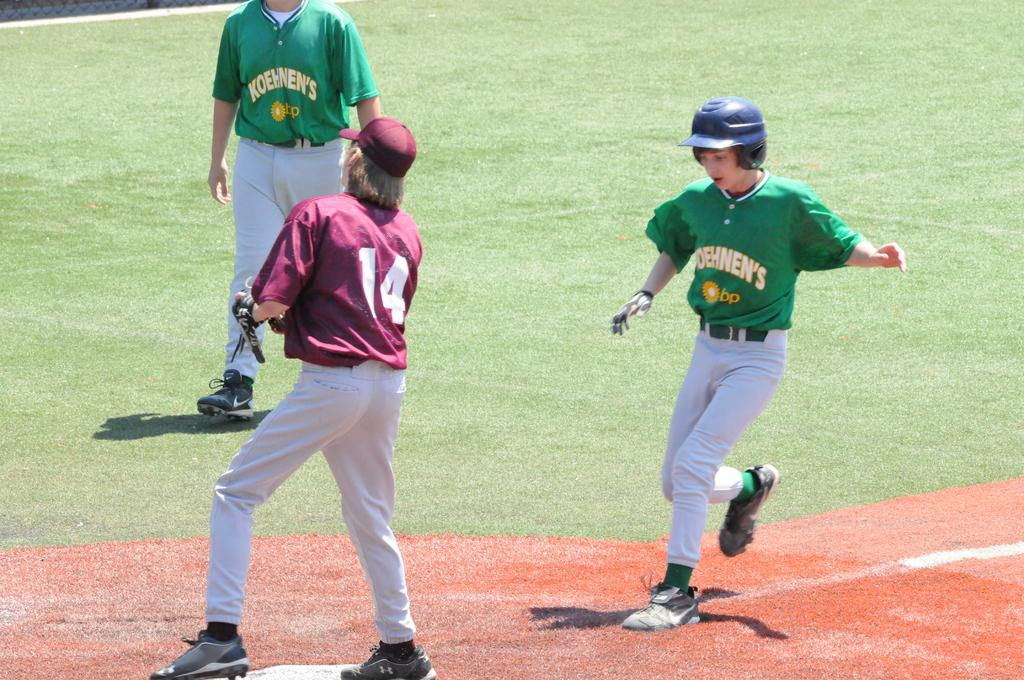<image>
Offer a succinct explanation of the picture presented. Young men are playing baseball wearing green Koehnen's jerseys. 